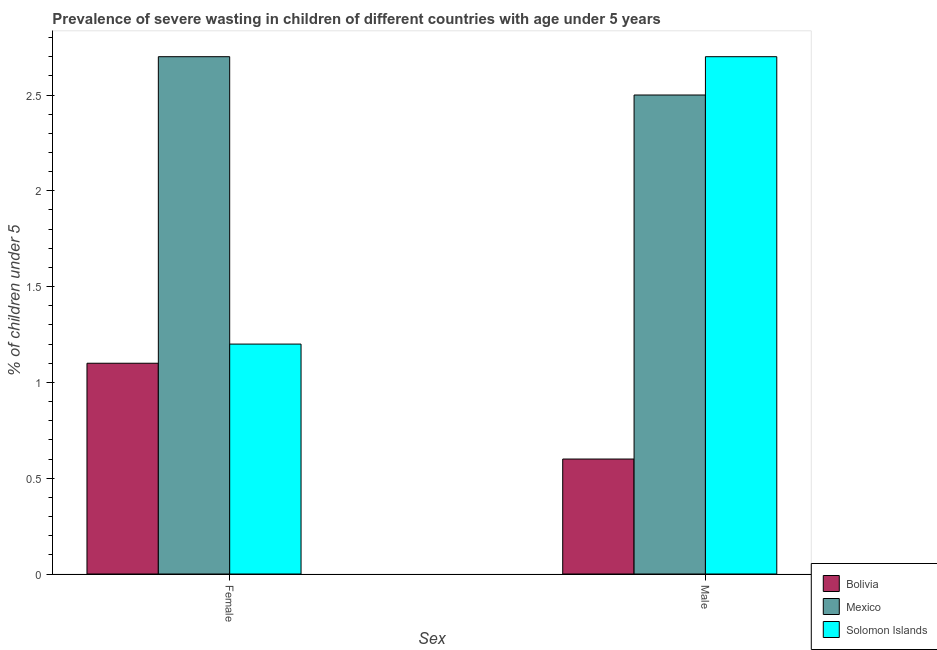How many different coloured bars are there?
Your answer should be very brief. 3. How many groups of bars are there?
Make the answer very short. 2. Are the number of bars per tick equal to the number of legend labels?
Your response must be concise. Yes. How many bars are there on the 1st tick from the left?
Your response must be concise. 3. How many bars are there on the 2nd tick from the right?
Offer a terse response. 3. What is the percentage of undernourished male children in Solomon Islands?
Offer a terse response. 2.7. Across all countries, what is the maximum percentage of undernourished female children?
Ensure brevity in your answer.  2.7. Across all countries, what is the minimum percentage of undernourished female children?
Provide a short and direct response. 1.1. In which country was the percentage of undernourished female children maximum?
Ensure brevity in your answer.  Mexico. What is the total percentage of undernourished male children in the graph?
Keep it short and to the point. 5.8. What is the difference between the percentage of undernourished female children in Mexico and that in Bolivia?
Offer a very short reply. 1.6. What is the difference between the percentage of undernourished female children in Bolivia and the percentage of undernourished male children in Mexico?
Keep it short and to the point. -1.4. What is the average percentage of undernourished female children per country?
Provide a succinct answer. 1.67. What is the difference between the percentage of undernourished male children and percentage of undernourished female children in Solomon Islands?
Offer a terse response. 1.5. What is the ratio of the percentage of undernourished male children in Mexico to that in Bolivia?
Make the answer very short. 4.17. What does the 3rd bar from the left in Female represents?
Provide a succinct answer. Solomon Islands. What is the difference between two consecutive major ticks on the Y-axis?
Your answer should be very brief. 0.5. Does the graph contain grids?
Make the answer very short. No. What is the title of the graph?
Your response must be concise. Prevalence of severe wasting in children of different countries with age under 5 years. Does "North America" appear as one of the legend labels in the graph?
Ensure brevity in your answer.  No. What is the label or title of the X-axis?
Your response must be concise. Sex. What is the label or title of the Y-axis?
Provide a short and direct response.  % of children under 5. What is the  % of children under 5 in Bolivia in Female?
Your answer should be compact. 1.1. What is the  % of children under 5 in Mexico in Female?
Offer a very short reply. 2.7. What is the  % of children under 5 of Solomon Islands in Female?
Offer a very short reply. 1.2. What is the  % of children under 5 of Bolivia in Male?
Your answer should be very brief. 0.6. What is the  % of children under 5 in Mexico in Male?
Provide a short and direct response. 2.5. What is the  % of children under 5 of Solomon Islands in Male?
Ensure brevity in your answer.  2.7. Across all Sex, what is the maximum  % of children under 5 of Bolivia?
Provide a short and direct response. 1.1. Across all Sex, what is the maximum  % of children under 5 in Mexico?
Offer a terse response. 2.7. Across all Sex, what is the maximum  % of children under 5 in Solomon Islands?
Provide a succinct answer. 2.7. Across all Sex, what is the minimum  % of children under 5 of Bolivia?
Offer a terse response. 0.6. Across all Sex, what is the minimum  % of children under 5 of Solomon Islands?
Give a very brief answer. 1.2. What is the total  % of children under 5 in Bolivia in the graph?
Offer a very short reply. 1.7. What is the difference between the  % of children under 5 in Solomon Islands in Female and that in Male?
Give a very brief answer. -1.5. What is the difference between the  % of children under 5 of Bolivia in Female and the  % of children under 5 of Mexico in Male?
Offer a very short reply. -1.4. What is the average  % of children under 5 of Mexico per Sex?
Offer a very short reply. 2.6. What is the average  % of children under 5 of Solomon Islands per Sex?
Your answer should be very brief. 1.95. What is the difference between the  % of children under 5 in Bolivia and  % of children under 5 in Mexico in Female?
Give a very brief answer. -1.6. What is the difference between the  % of children under 5 in Bolivia and  % of children under 5 in Solomon Islands in Female?
Offer a very short reply. -0.1. What is the difference between the  % of children under 5 of Mexico and  % of children under 5 of Solomon Islands in Male?
Provide a short and direct response. -0.2. What is the ratio of the  % of children under 5 of Bolivia in Female to that in Male?
Provide a short and direct response. 1.83. What is the ratio of the  % of children under 5 in Mexico in Female to that in Male?
Offer a very short reply. 1.08. What is the ratio of the  % of children under 5 in Solomon Islands in Female to that in Male?
Provide a short and direct response. 0.44. What is the difference between the highest and the second highest  % of children under 5 in Bolivia?
Make the answer very short. 0.5. What is the difference between the highest and the lowest  % of children under 5 of Bolivia?
Give a very brief answer. 0.5. 